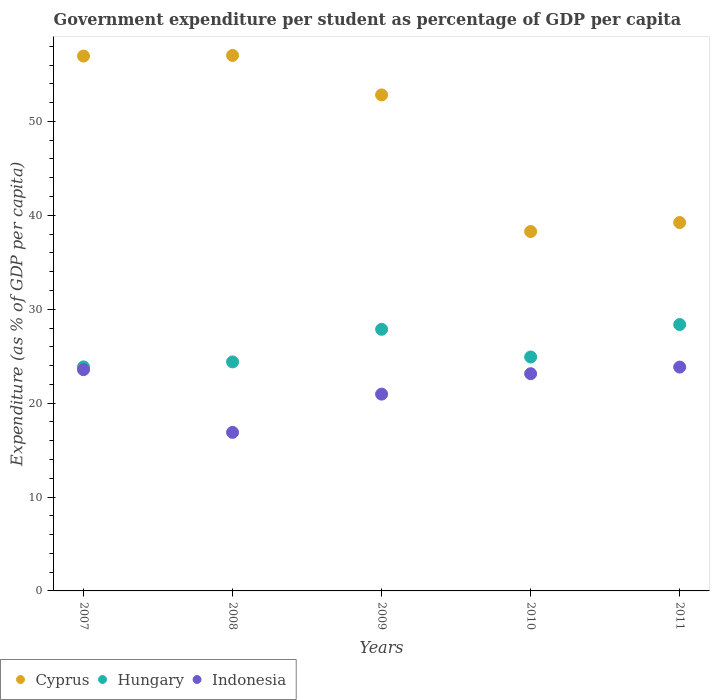How many different coloured dotlines are there?
Make the answer very short. 3. What is the percentage of expenditure per student in Hungary in 2009?
Provide a short and direct response. 27.86. Across all years, what is the maximum percentage of expenditure per student in Hungary?
Offer a terse response. 28.37. Across all years, what is the minimum percentage of expenditure per student in Indonesia?
Your answer should be very brief. 16.89. In which year was the percentage of expenditure per student in Hungary maximum?
Provide a short and direct response. 2011. What is the total percentage of expenditure per student in Indonesia in the graph?
Give a very brief answer. 108.38. What is the difference between the percentage of expenditure per student in Indonesia in 2007 and that in 2011?
Your answer should be very brief. -0.27. What is the difference between the percentage of expenditure per student in Indonesia in 2008 and the percentage of expenditure per student in Hungary in 2010?
Ensure brevity in your answer.  -8.03. What is the average percentage of expenditure per student in Cyprus per year?
Offer a terse response. 48.86. In the year 2008, what is the difference between the percentage of expenditure per student in Indonesia and percentage of expenditure per student in Hungary?
Ensure brevity in your answer.  -7.5. What is the ratio of the percentage of expenditure per student in Cyprus in 2008 to that in 2009?
Ensure brevity in your answer.  1.08. Is the percentage of expenditure per student in Hungary in 2007 less than that in 2008?
Your response must be concise. Yes. Is the difference between the percentage of expenditure per student in Indonesia in 2009 and 2010 greater than the difference between the percentage of expenditure per student in Hungary in 2009 and 2010?
Make the answer very short. No. What is the difference between the highest and the second highest percentage of expenditure per student in Cyprus?
Ensure brevity in your answer.  0.07. What is the difference between the highest and the lowest percentage of expenditure per student in Hungary?
Keep it short and to the point. 4.51. Is the sum of the percentage of expenditure per student in Indonesia in 2008 and 2011 greater than the maximum percentage of expenditure per student in Hungary across all years?
Offer a terse response. Yes. Does the percentage of expenditure per student in Hungary monotonically increase over the years?
Offer a very short reply. No. Is the percentage of expenditure per student in Cyprus strictly less than the percentage of expenditure per student in Indonesia over the years?
Offer a very short reply. No. How many dotlines are there?
Make the answer very short. 3. Are the values on the major ticks of Y-axis written in scientific E-notation?
Your answer should be very brief. No. What is the title of the graph?
Your answer should be very brief. Government expenditure per student as percentage of GDP per capita. Does "Syrian Arab Republic" appear as one of the legend labels in the graph?
Provide a short and direct response. No. What is the label or title of the Y-axis?
Offer a very short reply. Expenditure (as % of GDP per capita). What is the Expenditure (as % of GDP per capita) in Cyprus in 2007?
Provide a short and direct response. 56.96. What is the Expenditure (as % of GDP per capita) in Hungary in 2007?
Your answer should be very brief. 23.86. What is the Expenditure (as % of GDP per capita) of Indonesia in 2007?
Offer a very short reply. 23.56. What is the Expenditure (as % of GDP per capita) in Cyprus in 2008?
Keep it short and to the point. 57.03. What is the Expenditure (as % of GDP per capita) of Hungary in 2008?
Provide a succinct answer. 24.39. What is the Expenditure (as % of GDP per capita) in Indonesia in 2008?
Provide a short and direct response. 16.89. What is the Expenditure (as % of GDP per capita) of Cyprus in 2009?
Provide a short and direct response. 52.82. What is the Expenditure (as % of GDP per capita) in Hungary in 2009?
Offer a terse response. 27.86. What is the Expenditure (as % of GDP per capita) of Indonesia in 2009?
Provide a short and direct response. 20.96. What is the Expenditure (as % of GDP per capita) in Cyprus in 2010?
Your answer should be very brief. 38.28. What is the Expenditure (as % of GDP per capita) in Hungary in 2010?
Keep it short and to the point. 24.91. What is the Expenditure (as % of GDP per capita) in Indonesia in 2010?
Offer a terse response. 23.13. What is the Expenditure (as % of GDP per capita) in Cyprus in 2011?
Your response must be concise. 39.23. What is the Expenditure (as % of GDP per capita) in Hungary in 2011?
Provide a succinct answer. 28.37. What is the Expenditure (as % of GDP per capita) in Indonesia in 2011?
Ensure brevity in your answer.  23.84. Across all years, what is the maximum Expenditure (as % of GDP per capita) of Cyprus?
Give a very brief answer. 57.03. Across all years, what is the maximum Expenditure (as % of GDP per capita) in Hungary?
Keep it short and to the point. 28.37. Across all years, what is the maximum Expenditure (as % of GDP per capita) of Indonesia?
Provide a short and direct response. 23.84. Across all years, what is the minimum Expenditure (as % of GDP per capita) in Cyprus?
Give a very brief answer. 38.28. Across all years, what is the minimum Expenditure (as % of GDP per capita) in Hungary?
Offer a very short reply. 23.86. Across all years, what is the minimum Expenditure (as % of GDP per capita) of Indonesia?
Make the answer very short. 16.89. What is the total Expenditure (as % of GDP per capita) of Cyprus in the graph?
Ensure brevity in your answer.  244.32. What is the total Expenditure (as % of GDP per capita) in Hungary in the graph?
Give a very brief answer. 129.39. What is the total Expenditure (as % of GDP per capita) in Indonesia in the graph?
Give a very brief answer. 108.38. What is the difference between the Expenditure (as % of GDP per capita) of Cyprus in 2007 and that in 2008?
Provide a succinct answer. -0.07. What is the difference between the Expenditure (as % of GDP per capita) in Hungary in 2007 and that in 2008?
Your answer should be compact. -0.53. What is the difference between the Expenditure (as % of GDP per capita) of Indonesia in 2007 and that in 2008?
Provide a short and direct response. 6.68. What is the difference between the Expenditure (as % of GDP per capita) of Cyprus in 2007 and that in 2009?
Offer a very short reply. 4.14. What is the difference between the Expenditure (as % of GDP per capita) in Hungary in 2007 and that in 2009?
Offer a terse response. -4. What is the difference between the Expenditure (as % of GDP per capita) of Indonesia in 2007 and that in 2009?
Offer a terse response. 2.61. What is the difference between the Expenditure (as % of GDP per capita) in Cyprus in 2007 and that in 2010?
Your response must be concise. 18.68. What is the difference between the Expenditure (as % of GDP per capita) of Hungary in 2007 and that in 2010?
Your answer should be very brief. -1.05. What is the difference between the Expenditure (as % of GDP per capita) in Indonesia in 2007 and that in 2010?
Give a very brief answer. 0.43. What is the difference between the Expenditure (as % of GDP per capita) of Cyprus in 2007 and that in 2011?
Your answer should be very brief. 17.73. What is the difference between the Expenditure (as % of GDP per capita) in Hungary in 2007 and that in 2011?
Offer a very short reply. -4.51. What is the difference between the Expenditure (as % of GDP per capita) in Indonesia in 2007 and that in 2011?
Ensure brevity in your answer.  -0.27. What is the difference between the Expenditure (as % of GDP per capita) in Cyprus in 2008 and that in 2009?
Your response must be concise. 4.21. What is the difference between the Expenditure (as % of GDP per capita) of Hungary in 2008 and that in 2009?
Offer a very short reply. -3.47. What is the difference between the Expenditure (as % of GDP per capita) in Indonesia in 2008 and that in 2009?
Offer a very short reply. -4.07. What is the difference between the Expenditure (as % of GDP per capita) in Cyprus in 2008 and that in 2010?
Ensure brevity in your answer.  18.75. What is the difference between the Expenditure (as % of GDP per capita) in Hungary in 2008 and that in 2010?
Your answer should be compact. -0.52. What is the difference between the Expenditure (as % of GDP per capita) in Indonesia in 2008 and that in 2010?
Provide a succinct answer. -6.25. What is the difference between the Expenditure (as % of GDP per capita) of Cyprus in 2008 and that in 2011?
Your answer should be very brief. 17.8. What is the difference between the Expenditure (as % of GDP per capita) in Hungary in 2008 and that in 2011?
Offer a terse response. -3.98. What is the difference between the Expenditure (as % of GDP per capita) of Indonesia in 2008 and that in 2011?
Give a very brief answer. -6.95. What is the difference between the Expenditure (as % of GDP per capita) in Cyprus in 2009 and that in 2010?
Give a very brief answer. 14.55. What is the difference between the Expenditure (as % of GDP per capita) in Hungary in 2009 and that in 2010?
Make the answer very short. 2.95. What is the difference between the Expenditure (as % of GDP per capita) of Indonesia in 2009 and that in 2010?
Ensure brevity in your answer.  -2.17. What is the difference between the Expenditure (as % of GDP per capita) of Cyprus in 2009 and that in 2011?
Keep it short and to the point. 13.59. What is the difference between the Expenditure (as % of GDP per capita) in Hungary in 2009 and that in 2011?
Your answer should be very brief. -0.51. What is the difference between the Expenditure (as % of GDP per capita) in Indonesia in 2009 and that in 2011?
Provide a short and direct response. -2.88. What is the difference between the Expenditure (as % of GDP per capita) of Cyprus in 2010 and that in 2011?
Keep it short and to the point. -0.95. What is the difference between the Expenditure (as % of GDP per capita) of Hungary in 2010 and that in 2011?
Make the answer very short. -3.46. What is the difference between the Expenditure (as % of GDP per capita) of Indonesia in 2010 and that in 2011?
Your response must be concise. -0.7. What is the difference between the Expenditure (as % of GDP per capita) in Cyprus in 2007 and the Expenditure (as % of GDP per capita) in Hungary in 2008?
Ensure brevity in your answer.  32.57. What is the difference between the Expenditure (as % of GDP per capita) in Cyprus in 2007 and the Expenditure (as % of GDP per capita) in Indonesia in 2008?
Provide a succinct answer. 40.08. What is the difference between the Expenditure (as % of GDP per capita) of Hungary in 2007 and the Expenditure (as % of GDP per capita) of Indonesia in 2008?
Offer a very short reply. 6.97. What is the difference between the Expenditure (as % of GDP per capita) of Cyprus in 2007 and the Expenditure (as % of GDP per capita) of Hungary in 2009?
Provide a short and direct response. 29.1. What is the difference between the Expenditure (as % of GDP per capita) in Cyprus in 2007 and the Expenditure (as % of GDP per capita) in Indonesia in 2009?
Provide a succinct answer. 36. What is the difference between the Expenditure (as % of GDP per capita) of Hungary in 2007 and the Expenditure (as % of GDP per capita) of Indonesia in 2009?
Your answer should be compact. 2.9. What is the difference between the Expenditure (as % of GDP per capita) in Cyprus in 2007 and the Expenditure (as % of GDP per capita) in Hungary in 2010?
Offer a terse response. 32.05. What is the difference between the Expenditure (as % of GDP per capita) of Cyprus in 2007 and the Expenditure (as % of GDP per capita) of Indonesia in 2010?
Your answer should be very brief. 33.83. What is the difference between the Expenditure (as % of GDP per capita) of Hungary in 2007 and the Expenditure (as % of GDP per capita) of Indonesia in 2010?
Your answer should be very brief. 0.73. What is the difference between the Expenditure (as % of GDP per capita) of Cyprus in 2007 and the Expenditure (as % of GDP per capita) of Hungary in 2011?
Give a very brief answer. 28.59. What is the difference between the Expenditure (as % of GDP per capita) in Cyprus in 2007 and the Expenditure (as % of GDP per capita) in Indonesia in 2011?
Make the answer very short. 33.12. What is the difference between the Expenditure (as % of GDP per capita) of Hungary in 2007 and the Expenditure (as % of GDP per capita) of Indonesia in 2011?
Make the answer very short. 0.02. What is the difference between the Expenditure (as % of GDP per capita) of Cyprus in 2008 and the Expenditure (as % of GDP per capita) of Hungary in 2009?
Keep it short and to the point. 29.17. What is the difference between the Expenditure (as % of GDP per capita) of Cyprus in 2008 and the Expenditure (as % of GDP per capita) of Indonesia in 2009?
Provide a succinct answer. 36.07. What is the difference between the Expenditure (as % of GDP per capita) in Hungary in 2008 and the Expenditure (as % of GDP per capita) in Indonesia in 2009?
Offer a very short reply. 3.43. What is the difference between the Expenditure (as % of GDP per capita) in Cyprus in 2008 and the Expenditure (as % of GDP per capita) in Hungary in 2010?
Keep it short and to the point. 32.12. What is the difference between the Expenditure (as % of GDP per capita) in Cyprus in 2008 and the Expenditure (as % of GDP per capita) in Indonesia in 2010?
Make the answer very short. 33.9. What is the difference between the Expenditure (as % of GDP per capita) of Hungary in 2008 and the Expenditure (as % of GDP per capita) of Indonesia in 2010?
Offer a terse response. 1.26. What is the difference between the Expenditure (as % of GDP per capita) in Cyprus in 2008 and the Expenditure (as % of GDP per capita) in Hungary in 2011?
Make the answer very short. 28.66. What is the difference between the Expenditure (as % of GDP per capita) of Cyprus in 2008 and the Expenditure (as % of GDP per capita) of Indonesia in 2011?
Give a very brief answer. 33.19. What is the difference between the Expenditure (as % of GDP per capita) of Hungary in 2008 and the Expenditure (as % of GDP per capita) of Indonesia in 2011?
Ensure brevity in your answer.  0.55. What is the difference between the Expenditure (as % of GDP per capita) of Cyprus in 2009 and the Expenditure (as % of GDP per capita) of Hungary in 2010?
Your answer should be very brief. 27.91. What is the difference between the Expenditure (as % of GDP per capita) in Cyprus in 2009 and the Expenditure (as % of GDP per capita) in Indonesia in 2010?
Your answer should be very brief. 29.69. What is the difference between the Expenditure (as % of GDP per capita) of Hungary in 2009 and the Expenditure (as % of GDP per capita) of Indonesia in 2010?
Offer a very short reply. 4.73. What is the difference between the Expenditure (as % of GDP per capita) of Cyprus in 2009 and the Expenditure (as % of GDP per capita) of Hungary in 2011?
Keep it short and to the point. 24.45. What is the difference between the Expenditure (as % of GDP per capita) in Cyprus in 2009 and the Expenditure (as % of GDP per capita) in Indonesia in 2011?
Your answer should be very brief. 28.99. What is the difference between the Expenditure (as % of GDP per capita) of Hungary in 2009 and the Expenditure (as % of GDP per capita) of Indonesia in 2011?
Make the answer very short. 4.02. What is the difference between the Expenditure (as % of GDP per capita) in Cyprus in 2010 and the Expenditure (as % of GDP per capita) in Hungary in 2011?
Provide a succinct answer. 9.91. What is the difference between the Expenditure (as % of GDP per capita) of Cyprus in 2010 and the Expenditure (as % of GDP per capita) of Indonesia in 2011?
Your response must be concise. 14.44. What is the difference between the Expenditure (as % of GDP per capita) in Hungary in 2010 and the Expenditure (as % of GDP per capita) in Indonesia in 2011?
Your response must be concise. 1.08. What is the average Expenditure (as % of GDP per capita) of Cyprus per year?
Ensure brevity in your answer.  48.86. What is the average Expenditure (as % of GDP per capita) in Hungary per year?
Make the answer very short. 25.88. What is the average Expenditure (as % of GDP per capita) in Indonesia per year?
Provide a short and direct response. 21.68. In the year 2007, what is the difference between the Expenditure (as % of GDP per capita) of Cyprus and Expenditure (as % of GDP per capita) of Hungary?
Your answer should be compact. 33.1. In the year 2007, what is the difference between the Expenditure (as % of GDP per capita) of Cyprus and Expenditure (as % of GDP per capita) of Indonesia?
Ensure brevity in your answer.  33.4. In the year 2007, what is the difference between the Expenditure (as % of GDP per capita) of Hungary and Expenditure (as % of GDP per capita) of Indonesia?
Ensure brevity in your answer.  0.3. In the year 2008, what is the difference between the Expenditure (as % of GDP per capita) of Cyprus and Expenditure (as % of GDP per capita) of Hungary?
Make the answer very short. 32.64. In the year 2008, what is the difference between the Expenditure (as % of GDP per capita) of Cyprus and Expenditure (as % of GDP per capita) of Indonesia?
Offer a very short reply. 40.14. In the year 2008, what is the difference between the Expenditure (as % of GDP per capita) of Hungary and Expenditure (as % of GDP per capita) of Indonesia?
Ensure brevity in your answer.  7.5. In the year 2009, what is the difference between the Expenditure (as % of GDP per capita) in Cyprus and Expenditure (as % of GDP per capita) in Hungary?
Your answer should be very brief. 24.96. In the year 2009, what is the difference between the Expenditure (as % of GDP per capita) in Cyprus and Expenditure (as % of GDP per capita) in Indonesia?
Give a very brief answer. 31.86. In the year 2009, what is the difference between the Expenditure (as % of GDP per capita) of Hungary and Expenditure (as % of GDP per capita) of Indonesia?
Your answer should be compact. 6.9. In the year 2010, what is the difference between the Expenditure (as % of GDP per capita) of Cyprus and Expenditure (as % of GDP per capita) of Hungary?
Ensure brevity in your answer.  13.36. In the year 2010, what is the difference between the Expenditure (as % of GDP per capita) in Cyprus and Expenditure (as % of GDP per capita) in Indonesia?
Your response must be concise. 15.14. In the year 2010, what is the difference between the Expenditure (as % of GDP per capita) in Hungary and Expenditure (as % of GDP per capita) in Indonesia?
Provide a short and direct response. 1.78. In the year 2011, what is the difference between the Expenditure (as % of GDP per capita) of Cyprus and Expenditure (as % of GDP per capita) of Hungary?
Give a very brief answer. 10.86. In the year 2011, what is the difference between the Expenditure (as % of GDP per capita) in Cyprus and Expenditure (as % of GDP per capita) in Indonesia?
Provide a succinct answer. 15.39. In the year 2011, what is the difference between the Expenditure (as % of GDP per capita) of Hungary and Expenditure (as % of GDP per capita) of Indonesia?
Ensure brevity in your answer.  4.53. What is the ratio of the Expenditure (as % of GDP per capita) in Cyprus in 2007 to that in 2008?
Give a very brief answer. 1. What is the ratio of the Expenditure (as % of GDP per capita) in Hungary in 2007 to that in 2008?
Your response must be concise. 0.98. What is the ratio of the Expenditure (as % of GDP per capita) of Indonesia in 2007 to that in 2008?
Give a very brief answer. 1.4. What is the ratio of the Expenditure (as % of GDP per capita) in Cyprus in 2007 to that in 2009?
Offer a terse response. 1.08. What is the ratio of the Expenditure (as % of GDP per capita) in Hungary in 2007 to that in 2009?
Your answer should be very brief. 0.86. What is the ratio of the Expenditure (as % of GDP per capita) of Indonesia in 2007 to that in 2009?
Make the answer very short. 1.12. What is the ratio of the Expenditure (as % of GDP per capita) of Cyprus in 2007 to that in 2010?
Ensure brevity in your answer.  1.49. What is the ratio of the Expenditure (as % of GDP per capita) of Hungary in 2007 to that in 2010?
Make the answer very short. 0.96. What is the ratio of the Expenditure (as % of GDP per capita) in Indonesia in 2007 to that in 2010?
Keep it short and to the point. 1.02. What is the ratio of the Expenditure (as % of GDP per capita) of Cyprus in 2007 to that in 2011?
Provide a short and direct response. 1.45. What is the ratio of the Expenditure (as % of GDP per capita) of Hungary in 2007 to that in 2011?
Ensure brevity in your answer.  0.84. What is the ratio of the Expenditure (as % of GDP per capita) in Cyprus in 2008 to that in 2009?
Offer a very short reply. 1.08. What is the ratio of the Expenditure (as % of GDP per capita) of Hungary in 2008 to that in 2009?
Keep it short and to the point. 0.88. What is the ratio of the Expenditure (as % of GDP per capita) of Indonesia in 2008 to that in 2009?
Keep it short and to the point. 0.81. What is the ratio of the Expenditure (as % of GDP per capita) in Cyprus in 2008 to that in 2010?
Your response must be concise. 1.49. What is the ratio of the Expenditure (as % of GDP per capita) of Hungary in 2008 to that in 2010?
Give a very brief answer. 0.98. What is the ratio of the Expenditure (as % of GDP per capita) of Indonesia in 2008 to that in 2010?
Keep it short and to the point. 0.73. What is the ratio of the Expenditure (as % of GDP per capita) in Cyprus in 2008 to that in 2011?
Your answer should be very brief. 1.45. What is the ratio of the Expenditure (as % of GDP per capita) in Hungary in 2008 to that in 2011?
Make the answer very short. 0.86. What is the ratio of the Expenditure (as % of GDP per capita) of Indonesia in 2008 to that in 2011?
Provide a short and direct response. 0.71. What is the ratio of the Expenditure (as % of GDP per capita) of Cyprus in 2009 to that in 2010?
Provide a short and direct response. 1.38. What is the ratio of the Expenditure (as % of GDP per capita) of Hungary in 2009 to that in 2010?
Ensure brevity in your answer.  1.12. What is the ratio of the Expenditure (as % of GDP per capita) in Indonesia in 2009 to that in 2010?
Offer a very short reply. 0.91. What is the ratio of the Expenditure (as % of GDP per capita) of Cyprus in 2009 to that in 2011?
Offer a very short reply. 1.35. What is the ratio of the Expenditure (as % of GDP per capita) in Hungary in 2009 to that in 2011?
Your response must be concise. 0.98. What is the ratio of the Expenditure (as % of GDP per capita) of Indonesia in 2009 to that in 2011?
Give a very brief answer. 0.88. What is the ratio of the Expenditure (as % of GDP per capita) in Cyprus in 2010 to that in 2011?
Provide a short and direct response. 0.98. What is the ratio of the Expenditure (as % of GDP per capita) in Hungary in 2010 to that in 2011?
Provide a short and direct response. 0.88. What is the ratio of the Expenditure (as % of GDP per capita) of Indonesia in 2010 to that in 2011?
Ensure brevity in your answer.  0.97. What is the difference between the highest and the second highest Expenditure (as % of GDP per capita) of Cyprus?
Provide a short and direct response. 0.07. What is the difference between the highest and the second highest Expenditure (as % of GDP per capita) in Hungary?
Offer a terse response. 0.51. What is the difference between the highest and the second highest Expenditure (as % of GDP per capita) of Indonesia?
Make the answer very short. 0.27. What is the difference between the highest and the lowest Expenditure (as % of GDP per capita) of Cyprus?
Provide a succinct answer. 18.75. What is the difference between the highest and the lowest Expenditure (as % of GDP per capita) of Hungary?
Your answer should be compact. 4.51. What is the difference between the highest and the lowest Expenditure (as % of GDP per capita) of Indonesia?
Your response must be concise. 6.95. 